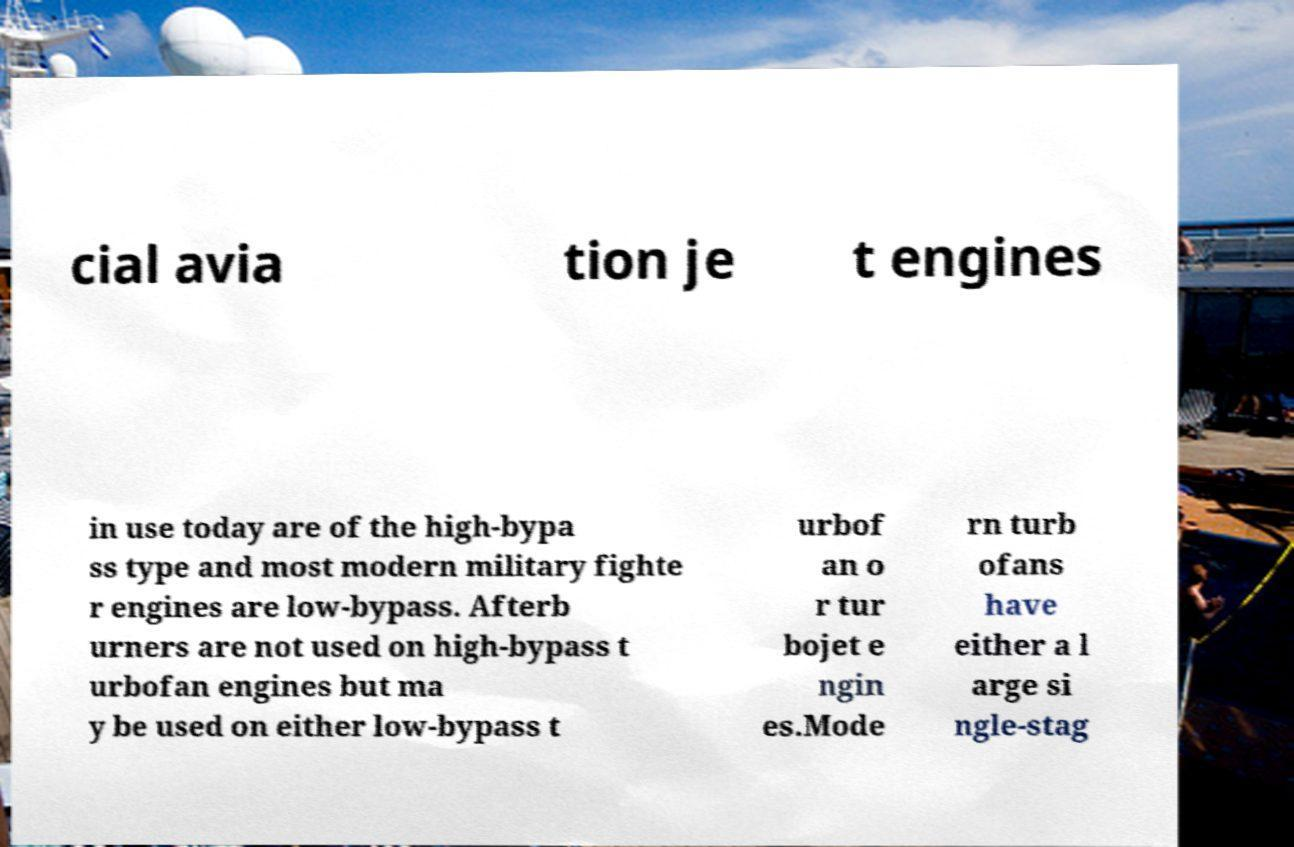Can you accurately transcribe the text from the provided image for me? cial avia tion je t engines in use today are of the high-bypa ss type and most modern military fighte r engines are low-bypass. Afterb urners are not used on high-bypass t urbofan engines but ma y be used on either low-bypass t urbof an o r tur bojet e ngin es.Mode rn turb ofans have either a l arge si ngle-stag 